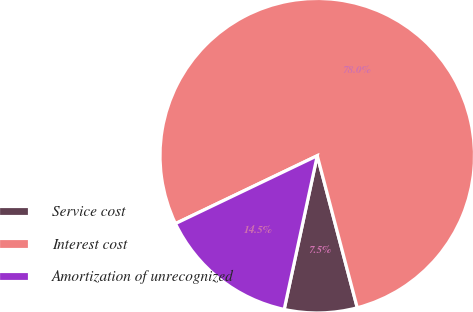<chart> <loc_0><loc_0><loc_500><loc_500><pie_chart><fcel>Service cost<fcel>Interest cost<fcel>Amortization of unrecognized<nl><fcel>7.47%<fcel>78.01%<fcel>14.52%<nl></chart> 